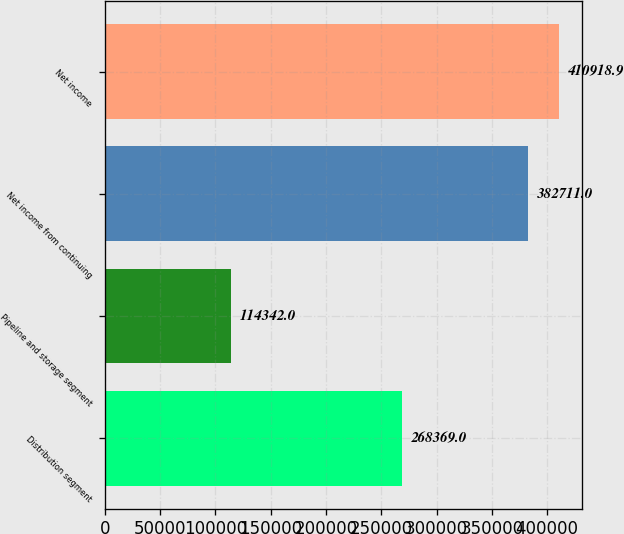<chart> <loc_0><loc_0><loc_500><loc_500><bar_chart><fcel>Distribution segment<fcel>Pipeline and storage segment<fcel>Net income from continuing<fcel>Net income<nl><fcel>268369<fcel>114342<fcel>382711<fcel>410919<nl></chart> 